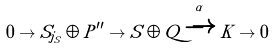Convert formula to latex. <formula><loc_0><loc_0><loc_500><loc_500>0 \to S _ { j _ { S } } \oplus P ^ { \prime \prime } \to S \oplus Q \xrightarrow { \alpha } K \to 0</formula> 